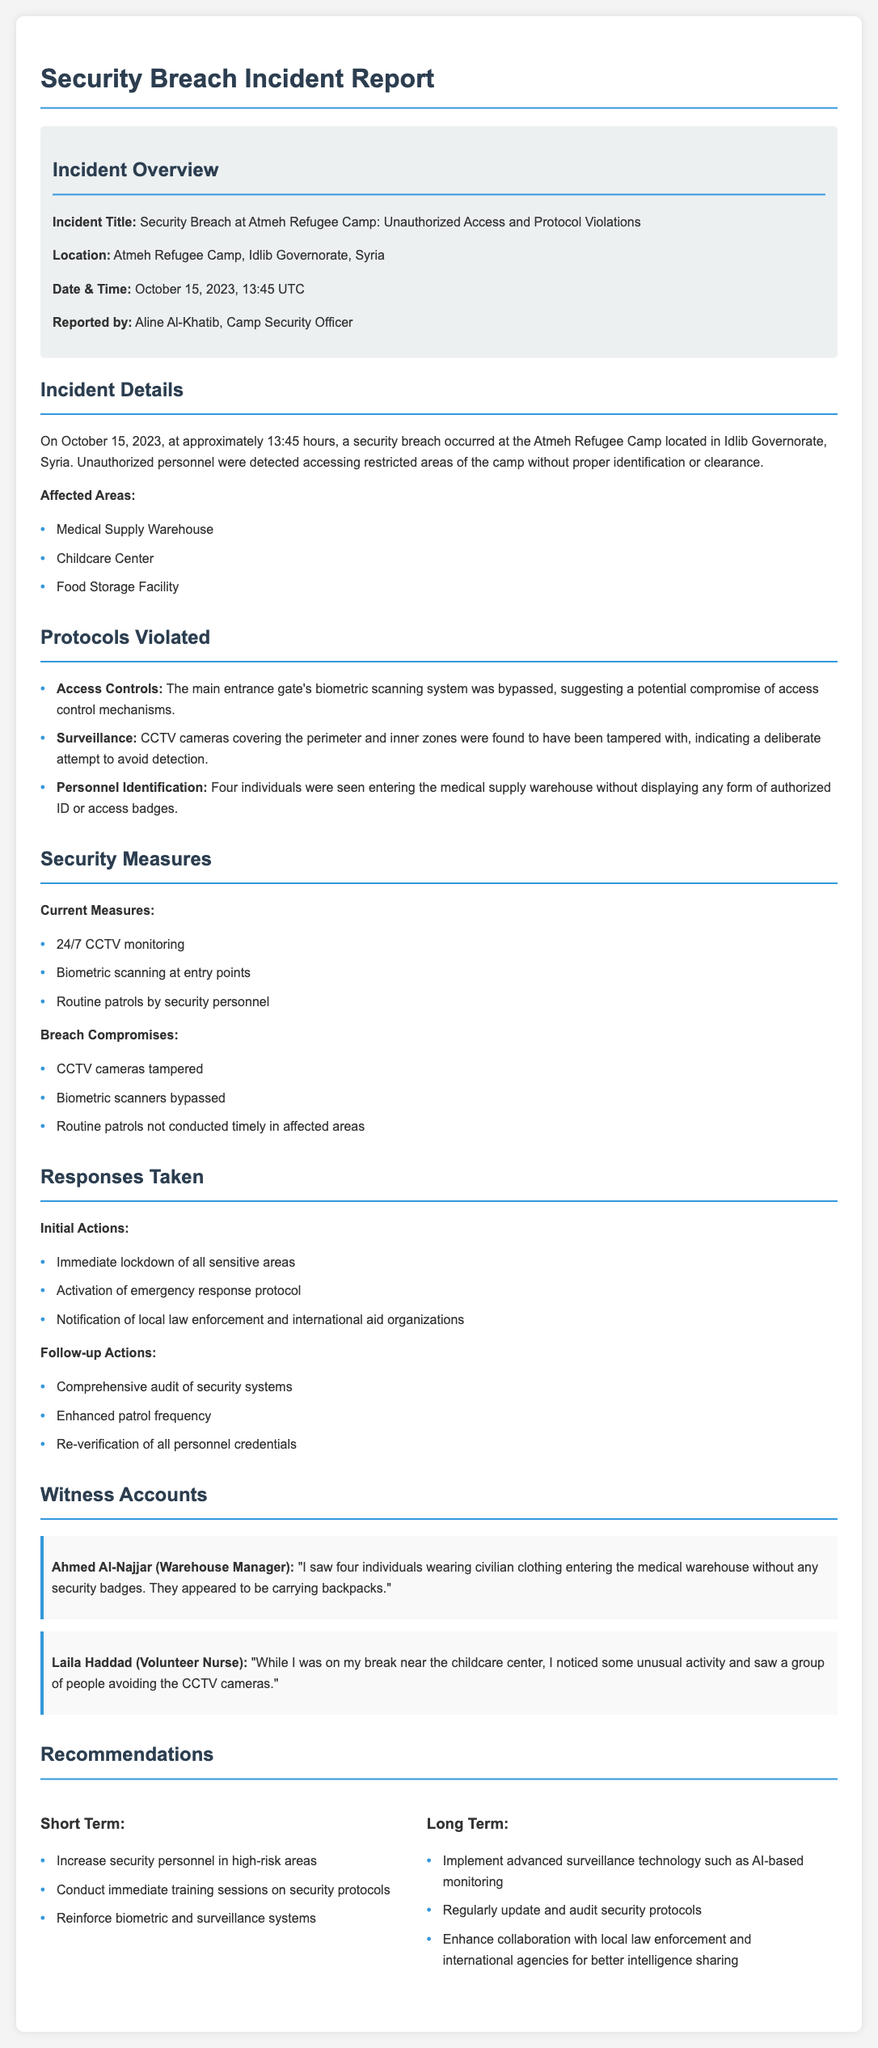What is the incident title? The incident title is clearly stated in the document under the incident overview section.
Answer: Security Breach at Atmeh Refugee Camp: Unauthorized Access and Protocol Violations Who reported the incident? The report mentions who reported the incident in the incident overview section.
Answer: Aline Al-Khatib What time did the incident occur? The time of the incident is specified in the incident overview section.
Answer: 13:45 UTC What areas were affected by the breach? The affected areas are listed under the incident details section, detailing the specific locations impacted.
Answer: Medical Supply Warehouse, Childcare Center, Food Storage Facility What was bypassed during the breach? The document specifies which security mechanism was compromised in the protocols violated section.
Answer: Biometric scanning system What actions were taken immediately after the breach? The initial actions taken are listed in the responses section, summarizing the immediate response to the incident.
Answer: Immediate lockdown of all sensitive areas What did Ahmed Al-Najjar see? Witness accounts detail what specific individuals witnessed during the incident, highlighting Ahmed's observations.
Answer: Four individuals wearing civilian clothing entering the medical warehouse without any security badges What is a short-term recommendation? The short-term recommendations are provided in the recommendations section focusing on immediate improvements.
Answer: Increase security personnel in high-risk areas What type of monitoring is currently used? The document lists current security measures, including the type of monitoring in place.
Answer: 24/7 CCTV monitoring 